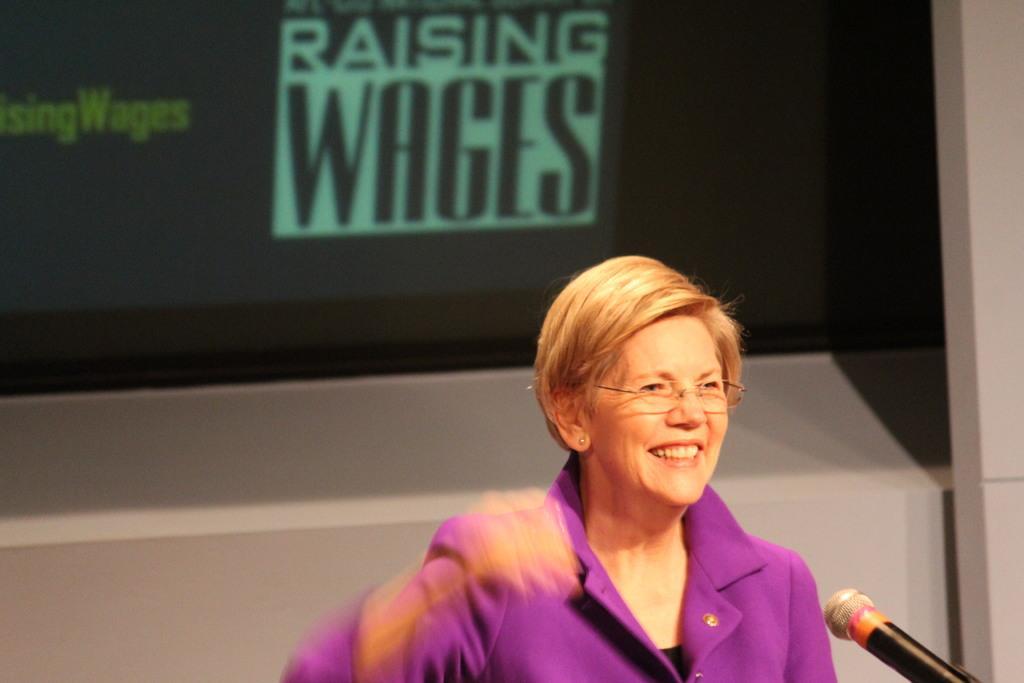Please provide a concise description of this image. In this picture I can see a woman is smiling. The woman is wearing spectacles and a purple color dress. Here I can see a microphone. In the background, I can see a logo. 